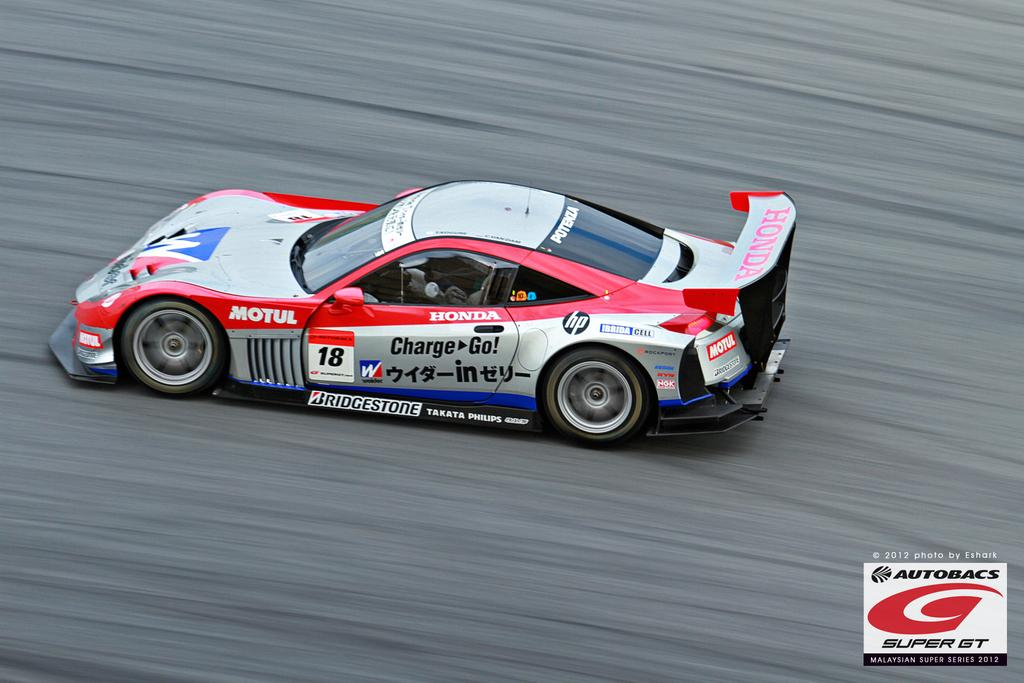What type of vehicle is in the image? There is a sports car in the image. Where is the sports car located? The sports car is on the road. Are there any distinguishing features on the sports car? Yes, there are logos on the sports car. Is there any additional information about the image itself? Yes, there is a watermark in the image. Can you see any sea creatures near the sports car in the image? There are no sea creatures present in the image; it features a sports car on the road. What type of fang is visible on the sports car in the image? There is no fang present on the sports car in the image. 